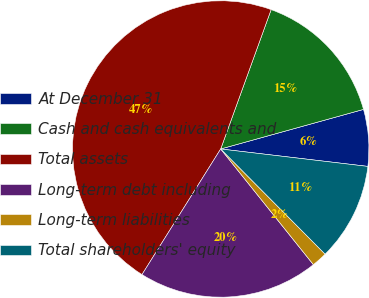<chart> <loc_0><loc_0><loc_500><loc_500><pie_chart><fcel>At December 31<fcel>Cash and cash equivalents and<fcel>Total assets<fcel>Long-term debt including<fcel>Long-term liabilities<fcel>Total shareholders' equity<nl><fcel>6.18%<fcel>15.17%<fcel>46.62%<fcel>19.66%<fcel>1.69%<fcel>10.68%<nl></chart> 